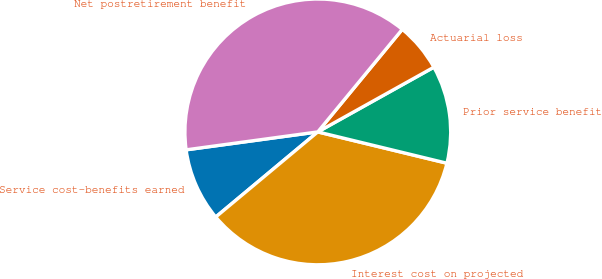<chart> <loc_0><loc_0><loc_500><loc_500><pie_chart><fcel>Service cost-benefits earned<fcel>Interest cost on projected<fcel>Prior service benefit<fcel>Actuarial loss<fcel>Net postretirement benefit<nl><fcel>8.91%<fcel>35.15%<fcel>11.88%<fcel>5.94%<fcel>38.12%<nl></chart> 